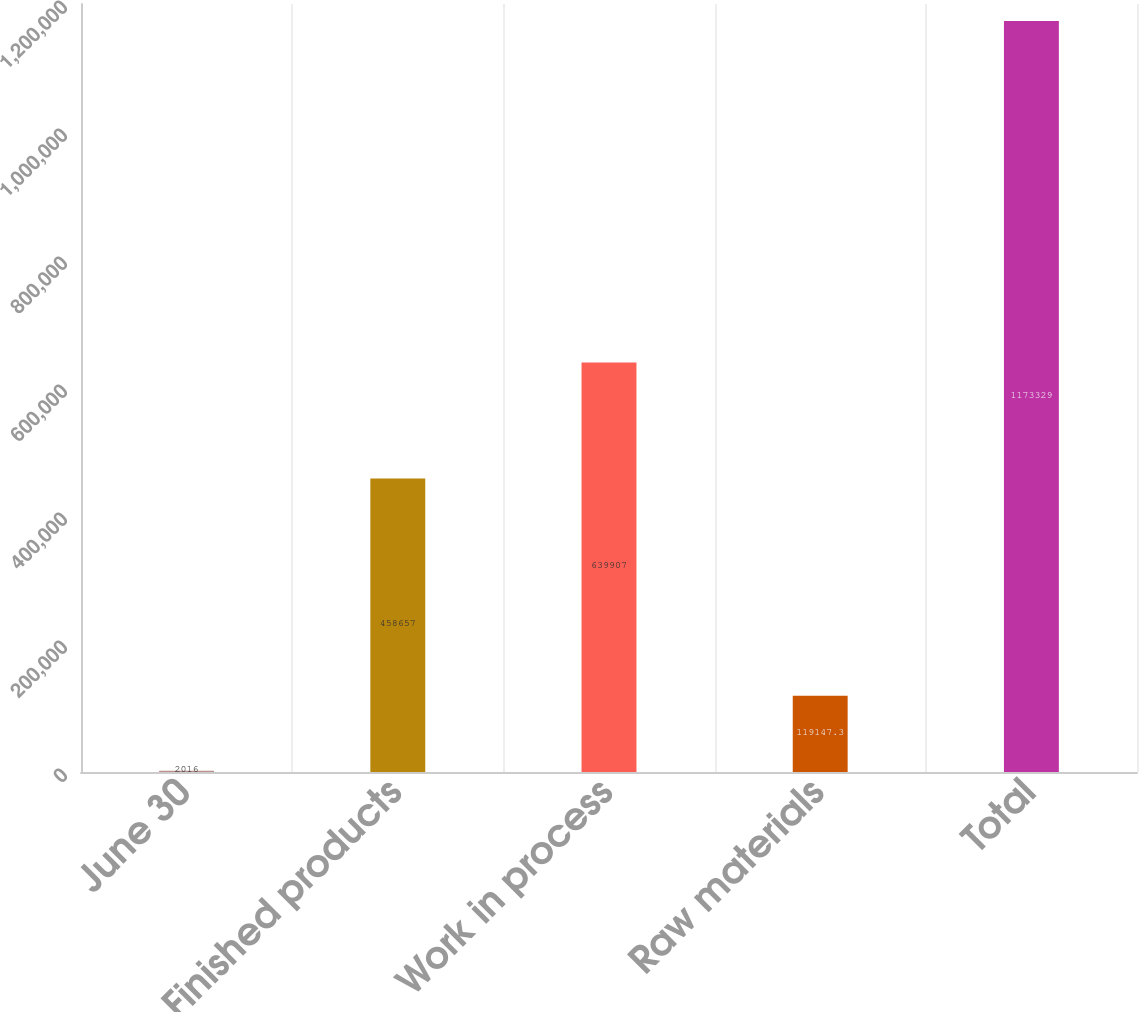Convert chart. <chart><loc_0><loc_0><loc_500><loc_500><bar_chart><fcel>June 30<fcel>Finished products<fcel>Work in process<fcel>Raw materials<fcel>Total<nl><fcel>2016<fcel>458657<fcel>639907<fcel>119147<fcel>1.17333e+06<nl></chart> 